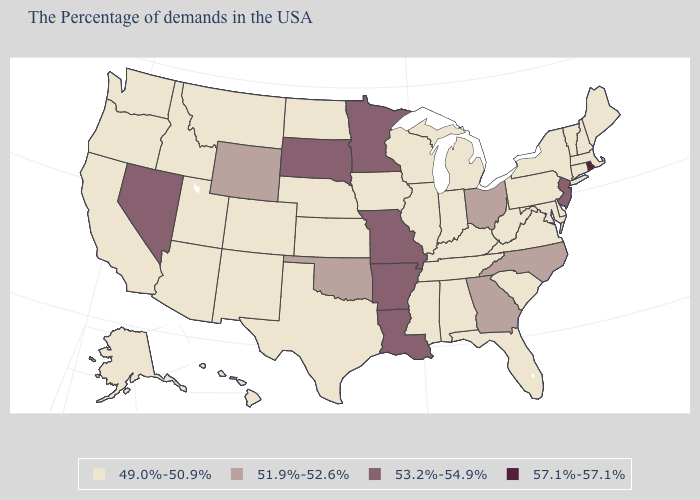Does Oklahoma have a higher value than Wyoming?
Be succinct. No. What is the lowest value in the USA?
Concise answer only. 49.0%-50.9%. What is the value of North Carolina?
Concise answer only. 51.9%-52.6%. What is the value of Virginia?
Concise answer only. 49.0%-50.9%. What is the value of Tennessee?
Answer briefly. 49.0%-50.9%. Does the first symbol in the legend represent the smallest category?
Answer briefly. Yes. Does the first symbol in the legend represent the smallest category?
Answer briefly. Yes. What is the value of Rhode Island?
Short answer required. 57.1%-57.1%. Which states have the lowest value in the USA?
Short answer required. Maine, Massachusetts, New Hampshire, Vermont, Connecticut, New York, Delaware, Maryland, Pennsylvania, Virginia, South Carolina, West Virginia, Florida, Michigan, Kentucky, Indiana, Alabama, Tennessee, Wisconsin, Illinois, Mississippi, Iowa, Kansas, Nebraska, Texas, North Dakota, Colorado, New Mexico, Utah, Montana, Arizona, Idaho, California, Washington, Oregon, Alaska, Hawaii. What is the value of Missouri?
Write a very short answer. 53.2%-54.9%. Does North Carolina have a higher value than Kentucky?
Write a very short answer. Yes. Among the states that border Wyoming , does Idaho have the highest value?
Keep it brief. No. Name the states that have a value in the range 51.9%-52.6%?
Answer briefly. North Carolina, Ohio, Georgia, Oklahoma, Wyoming. What is the value of Wisconsin?
Quick response, please. 49.0%-50.9%. Does the first symbol in the legend represent the smallest category?
Short answer required. Yes. 